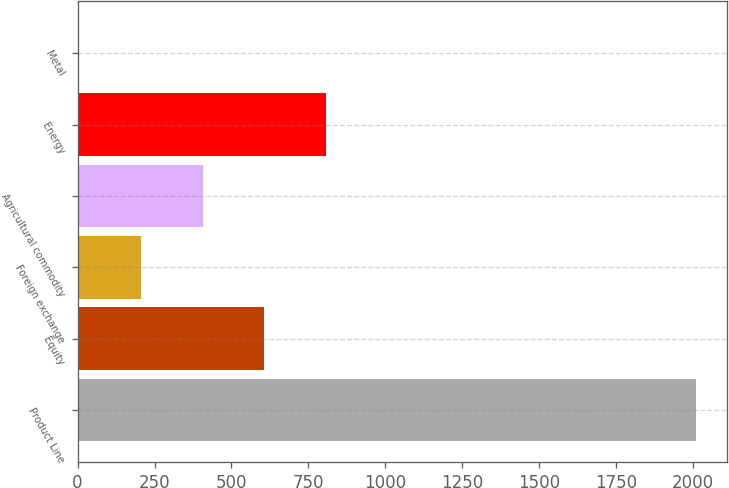Convert chart to OTSL. <chart><loc_0><loc_0><loc_500><loc_500><bar_chart><fcel>Product Line<fcel>Equity<fcel>Foreign exchange<fcel>Agricultural commodity<fcel>Energy<fcel>Metal<nl><fcel>2010<fcel>607.2<fcel>206.4<fcel>406.8<fcel>807.6<fcel>6<nl></chart> 